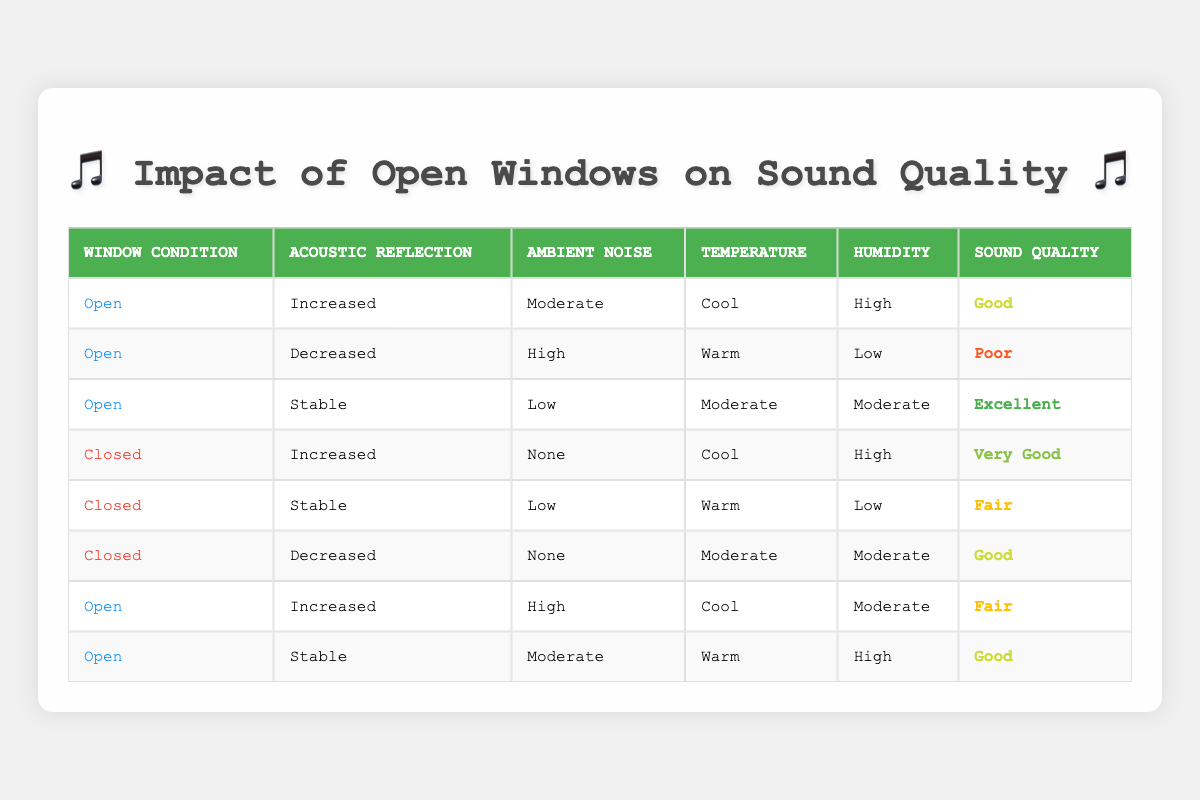What is the sound quality when the windows are open and acoustic reflection is stable? In the table, the row with "Open" for window condition and "Stable" for acoustic reflection indicates that the corresponding sound quality is "Excellent."
Answer: Excellent How many total entries in the table indicate poor sound quality? The table lists 8 entries, and upon reviewing these, there are 2 instances where the sound quality is labeled "Poor."
Answer: 2 Is there any condition where closed windows result in very good sound quality? Looking through the table, there is one entry for closed windows which shows the sound quality as "Very Good." Thus, the answer is yes.
Answer: Yes What are the ambient noise levels when the windows are open? The table shows that when the windows are open, the ambient noise levels are classified as "Moderate," "High," "Low," and "High," indicating variability based on different conditions.
Answer: Moderate, High, Low, High What is the difference in sound quality between open and closed windows when the acoustic reflection is increased? For open windows with increased reflection, the sound quality is "Good," while for closed windows, it is "Very Good." The difference indicates that closed windows have one level higher sound quality.
Answer: One level higher How many times do the windows being open correlate with good or excellent sound quality? Reviewing the table, when the windows are open, "Good" sound quality appears 3 times, and "Excellent" appears once, totaling 4 instances of good or excellent sound quality.
Answer: 4 